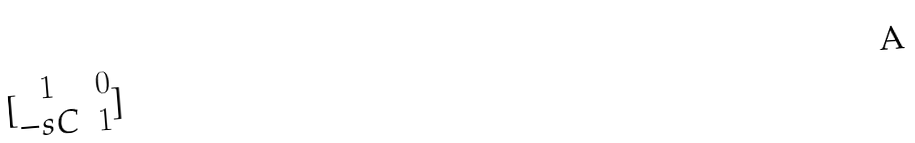<formula> <loc_0><loc_0><loc_500><loc_500>[ \begin{matrix} 1 & 0 \\ - s C & 1 \end{matrix} ]</formula> 